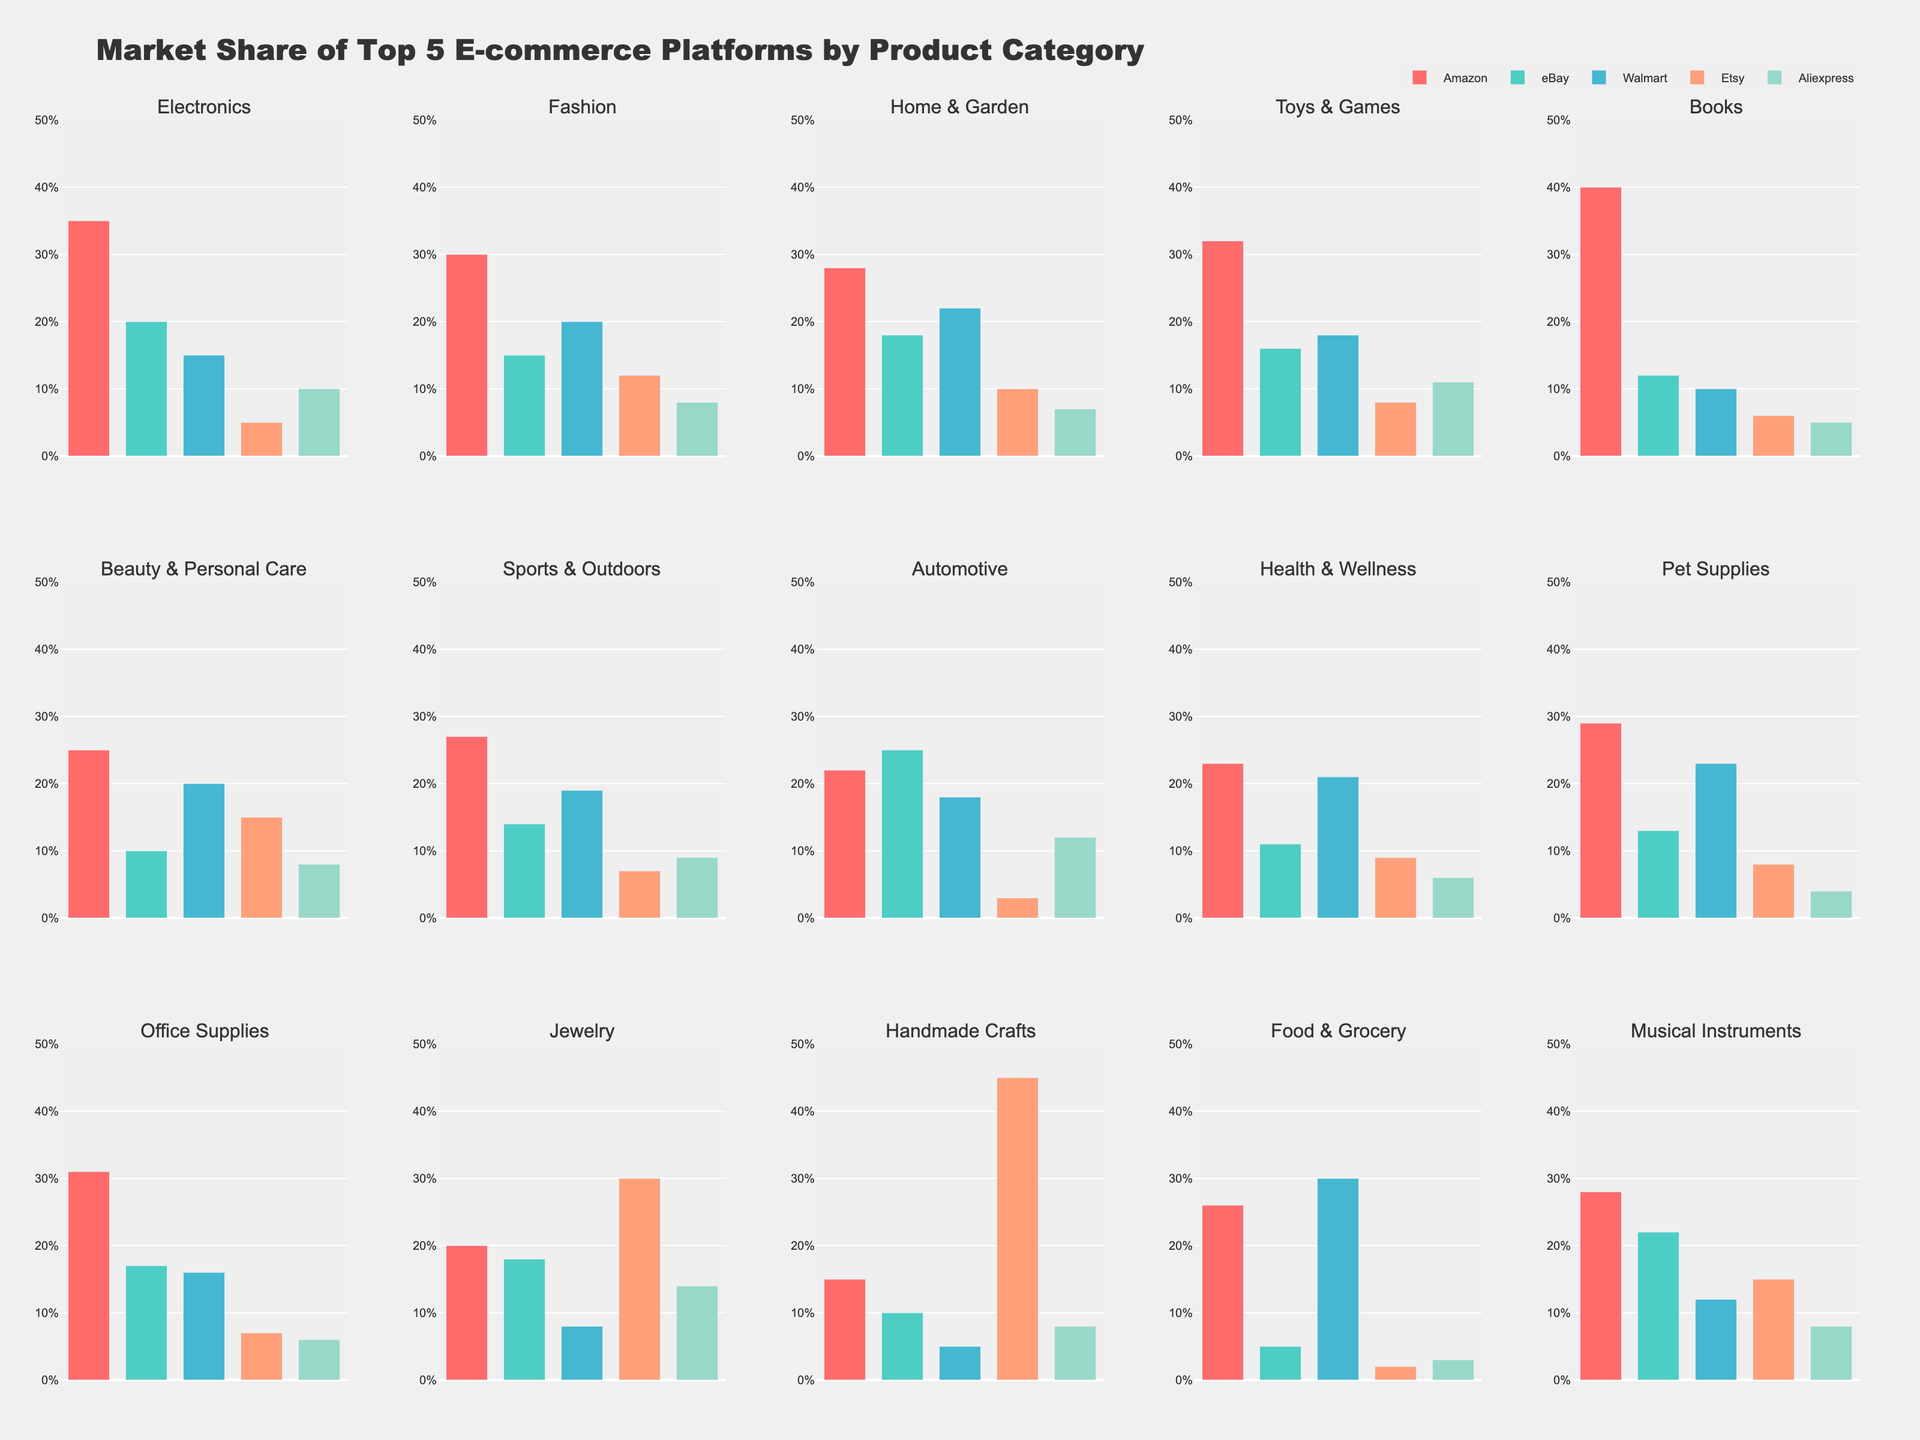Which e-commerce platform has the highest market share in the Electronics category? By looking at the bar height for the Electronics category, Amazon has the tallest bar.
Answer: Amazon Which product category does Etsy lead in market share? By observing the subplots for each product category, the bar for Etsy is highest in the Handmade Crafts category.
Answer: Handmade Crafts Between Amazon and Walmart, which platform has a higher market share in the Food & Grocery category, and by how much? Comparing the bar heights for Amazon and Walmart in the Food & Grocery subplot, Walmart (30%) has a higher share than Amazon (26%). The difference is 30 - 26 = 4.
Answer: Walmart by 4% What is the combined market share for eBay and Aliexpress in the Automotive category? Adding the market shares for eBay (25%) and Aliexpress (12%) in the Automotive subplot, the combined share is 25 + 12 = 37%.
Answer: 37% Which category shows the highest market share for Amazon, and what is that share? By scanning the subplots for the tallest bar representing Amazon, the Books category has the highest bar at 40%.
Answer: Books with 40% In which product category is the market share difference between Fashion and Jewelry greatest? Observing both subplots, Amazon's share in Fashion is 30%, and in Jewelry, it is 20%. The difference is 30 - 20 = 10.
Answer: Fashion by 10 Which e-commerce platform has relatively uniform market shares across categories? By looking at the bar heights in multiple subplots for each platform, Walmart appears to have the most consistent bars across categories.
Answer: Walmart What's the average market share of Walmart across all categories? Summing up Walmart's shares (15+20+22+18+10+20+19+18+21+23+16+8+5+30+12) and dividing by 15, the average is (15+20+22+18+10+20+19+18+21+23+16+8+5+30+12)/15 = 18.53%.
Answer: 18.53% Does any platform have a higher market share in the Toys & Games category than in the Pet Supplies category? Which one? Comparing the bar heights, Amazon has a 32% share in Toys & Games and a 29% share in Pet Supplies, which is higher.
Answer: Amazon 